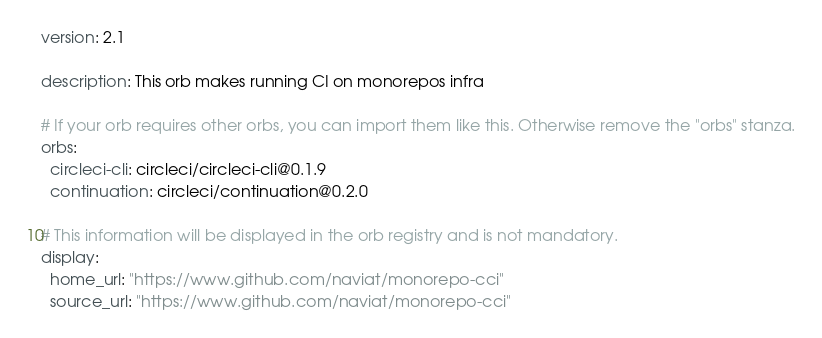<code> <loc_0><loc_0><loc_500><loc_500><_YAML_>version: 2.1

description: This orb makes running CI on monorepos infra

# If your orb requires other orbs, you can import them like this. Otherwise remove the "orbs" stanza.
orbs:
  circleci-cli: circleci/circleci-cli@0.1.9
  continuation: circleci/continuation@0.2.0

# This information will be displayed in the orb registry and is not mandatory.
display:
  home_url: "https://www.github.com/naviat/monorepo-cci"
  source_url: "https://www.github.com/naviat/monorepo-cci"
</code> 